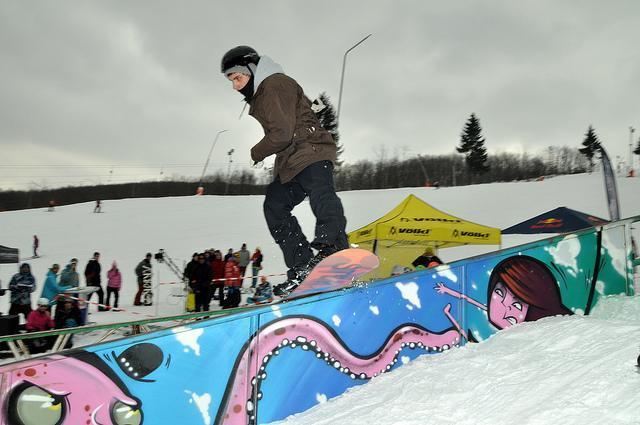How many people are there?
Give a very brief answer. 2. 